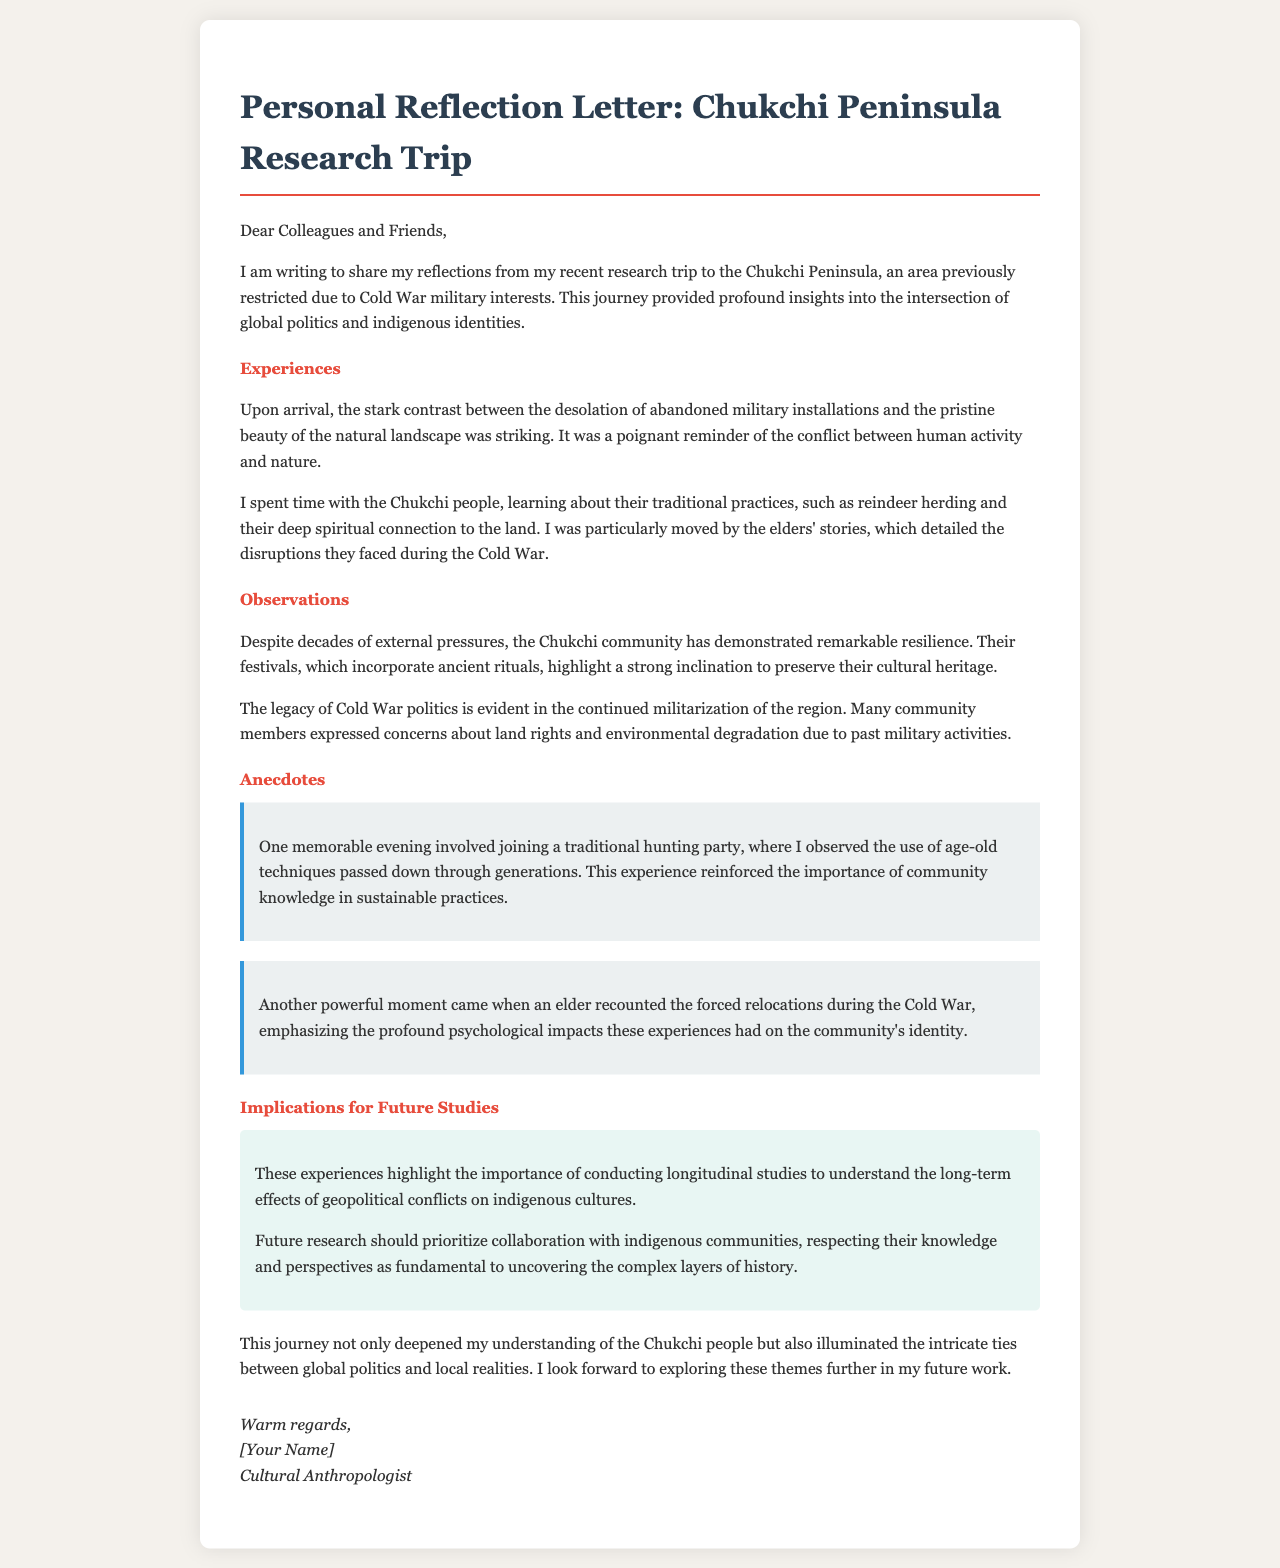What is the location of the research trip? The document states the research trip took place in the Chukchi Peninsula.
Answer: Chukchi Peninsula What was previously restricted due to Cold War military interests? The text mentions that the Chukchi Peninsula was restricted due to Cold War military interests.
Answer: Chukchi Peninsula Who did the author spend time with during the trip? The author spent time with the Chukchi people, as mentioned in the experiences section.
Answer: Chukchi people What traditional practice was highlighted in the research? The document highlights reindeer herding as a traditional practice.
Answer: Reindeer herding What is one implication for future studies mentioned? The letter suggests conducting longitudinal studies to understand long-term effects.
Answer: Longitudinal studies How did the community react to past military activities? The community expressed concerns about land rights and environmental degradation.
Answer: Concerns about land rights and environmental degradation What did the elder recount regarding the Cold War? An elder recounted forced relocations during the Cold War.
Answer: Forced relocations What genre of writing is this document? The document is a personal reflection letter.
Answer: Personal reflection letter 